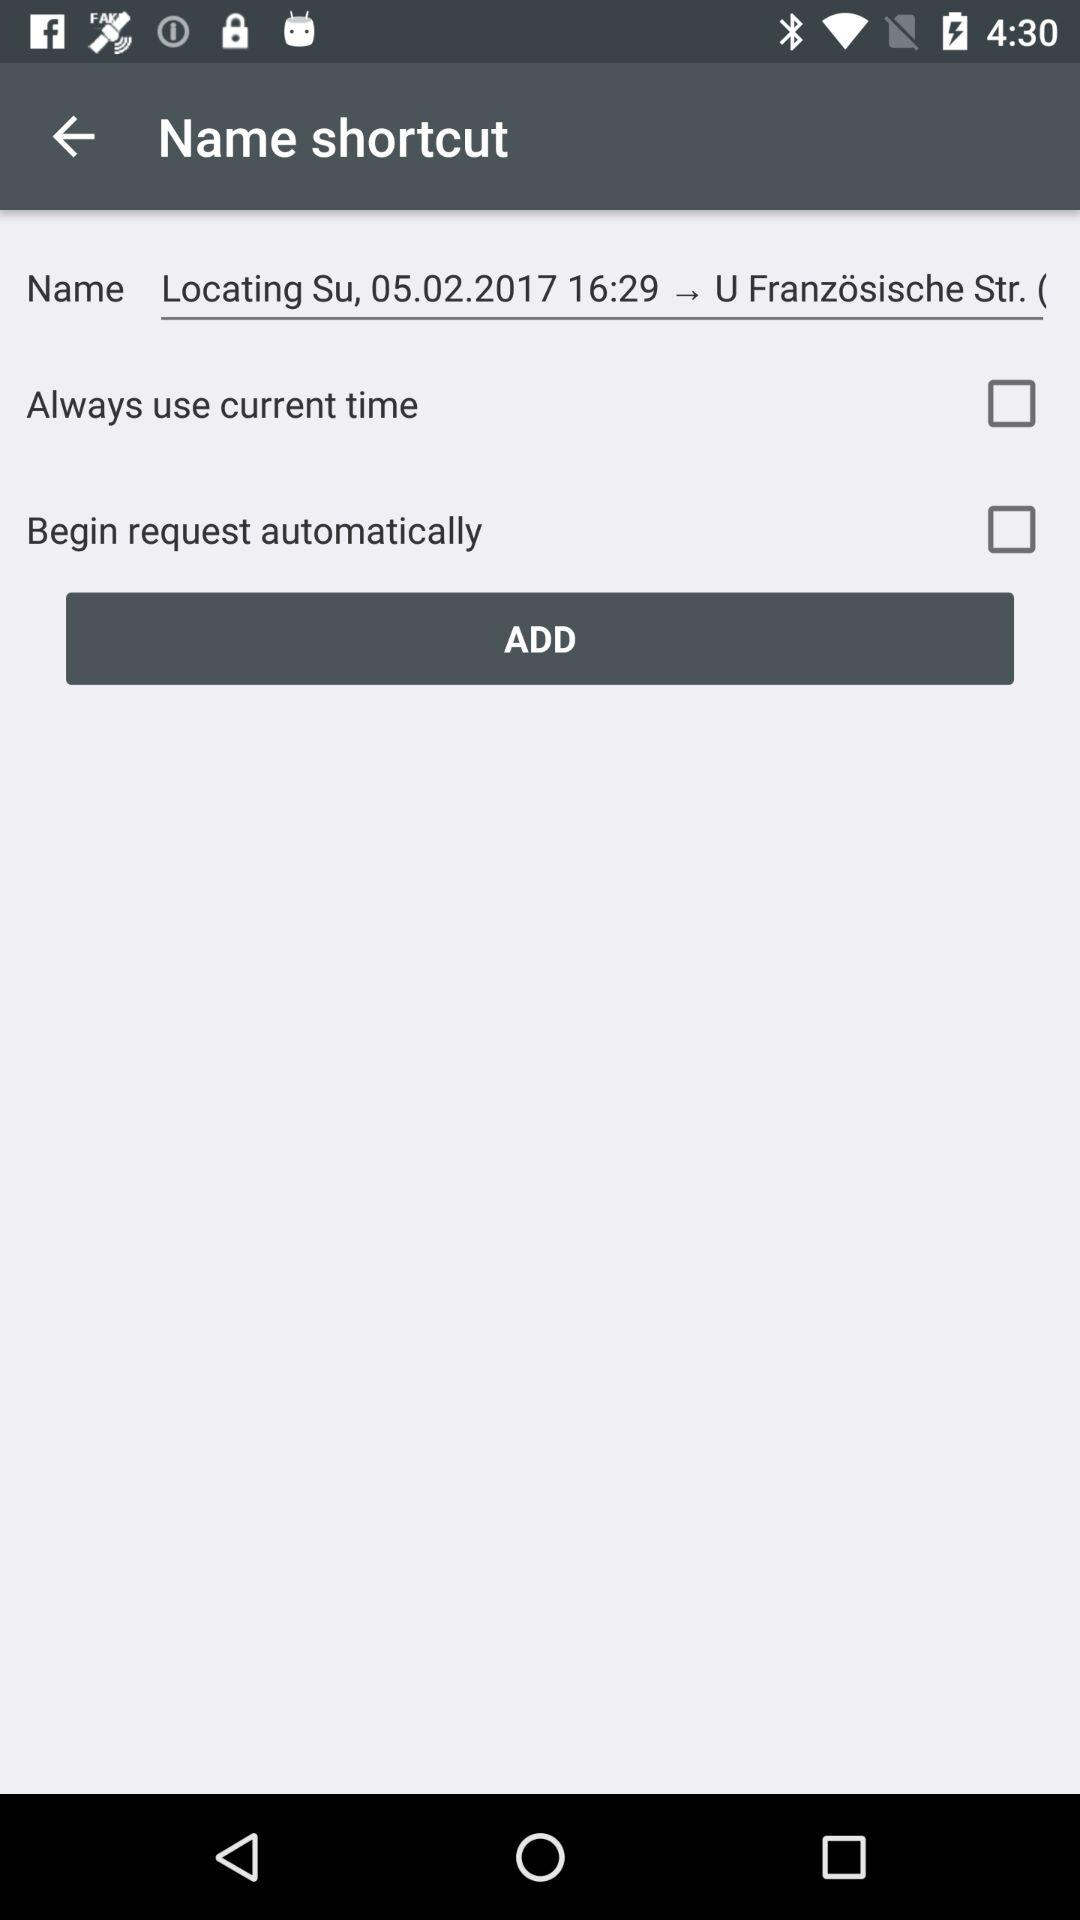What is the Name?
When the provided information is insufficient, respond with <no answer>. <no answer> 